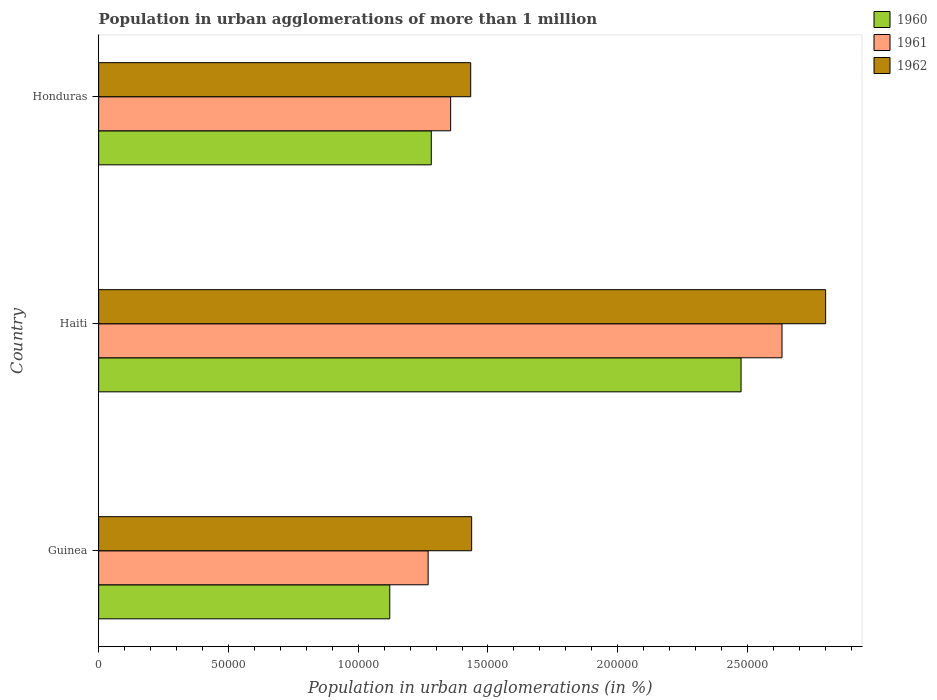How many bars are there on the 1st tick from the bottom?
Offer a terse response. 3. What is the label of the 3rd group of bars from the top?
Offer a very short reply. Guinea. In how many cases, is the number of bars for a given country not equal to the number of legend labels?
Offer a terse response. 0. What is the population in urban agglomerations in 1960 in Guinea?
Your response must be concise. 1.12e+05. Across all countries, what is the maximum population in urban agglomerations in 1960?
Provide a succinct answer. 2.47e+05. Across all countries, what is the minimum population in urban agglomerations in 1962?
Provide a succinct answer. 1.43e+05. In which country was the population in urban agglomerations in 1961 maximum?
Ensure brevity in your answer.  Haiti. In which country was the population in urban agglomerations in 1962 minimum?
Ensure brevity in your answer.  Honduras. What is the total population in urban agglomerations in 1962 in the graph?
Provide a short and direct response. 5.67e+05. What is the difference between the population in urban agglomerations in 1960 in Guinea and that in Haiti?
Offer a very short reply. -1.35e+05. What is the difference between the population in urban agglomerations in 1961 in Honduras and the population in urban agglomerations in 1962 in Haiti?
Offer a very short reply. -1.44e+05. What is the average population in urban agglomerations in 1961 per country?
Your response must be concise. 1.75e+05. What is the difference between the population in urban agglomerations in 1960 and population in urban agglomerations in 1962 in Honduras?
Provide a short and direct response. -1.52e+04. In how many countries, is the population in urban agglomerations in 1962 greater than 190000 %?
Provide a succinct answer. 1. What is the ratio of the population in urban agglomerations in 1960 in Guinea to that in Honduras?
Your answer should be compact. 0.88. Is the difference between the population in urban agglomerations in 1960 in Guinea and Honduras greater than the difference between the population in urban agglomerations in 1962 in Guinea and Honduras?
Your answer should be very brief. No. What is the difference between the highest and the second highest population in urban agglomerations in 1962?
Keep it short and to the point. 1.36e+05. What is the difference between the highest and the lowest population in urban agglomerations in 1962?
Your answer should be compact. 1.37e+05. In how many countries, is the population in urban agglomerations in 1962 greater than the average population in urban agglomerations in 1962 taken over all countries?
Offer a terse response. 1. Is the sum of the population in urban agglomerations in 1962 in Guinea and Haiti greater than the maximum population in urban agglomerations in 1961 across all countries?
Provide a short and direct response. Yes. What does the 2nd bar from the top in Haiti represents?
Provide a succinct answer. 1961. Are all the bars in the graph horizontal?
Keep it short and to the point. Yes. What is the difference between two consecutive major ticks on the X-axis?
Ensure brevity in your answer.  5.00e+04. Does the graph contain any zero values?
Keep it short and to the point. No. Does the graph contain grids?
Keep it short and to the point. No. Where does the legend appear in the graph?
Make the answer very short. Top right. What is the title of the graph?
Provide a short and direct response. Population in urban agglomerations of more than 1 million. Does "1991" appear as one of the legend labels in the graph?
Provide a short and direct response. No. What is the label or title of the X-axis?
Your answer should be very brief. Population in urban agglomerations (in %). What is the Population in urban agglomerations (in %) in 1960 in Guinea?
Offer a terse response. 1.12e+05. What is the Population in urban agglomerations (in %) of 1961 in Guinea?
Offer a very short reply. 1.27e+05. What is the Population in urban agglomerations (in %) of 1962 in Guinea?
Ensure brevity in your answer.  1.44e+05. What is the Population in urban agglomerations (in %) of 1960 in Haiti?
Provide a short and direct response. 2.47e+05. What is the Population in urban agglomerations (in %) of 1961 in Haiti?
Offer a terse response. 2.63e+05. What is the Population in urban agglomerations (in %) in 1962 in Haiti?
Offer a very short reply. 2.80e+05. What is the Population in urban agglomerations (in %) in 1960 in Honduras?
Your response must be concise. 1.28e+05. What is the Population in urban agglomerations (in %) of 1961 in Honduras?
Make the answer very short. 1.36e+05. What is the Population in urban agglomerations (in %) in 1962 in Honduras?
Ensure brevity in your answer.  1.43e+05. Across all countries, what is the maximum Population in urban agglomerations (in %) in 1960?
Offer a very short reply. 2.47e+05. Across all countries, what is the maximum Population in urban agglomerations (in %) in 1961?
Ensure brevity in your answer.  2.63e+05. Across all countries, what is the maximum Population in urban agglomerations (in %) of 1962?
Your answer should be very brief. 2.80e+05. Across all countries, what is the minimum Population in urban agglomerations (in %) in 1960?
Keep it short and to the point. 1.12e+05. Across all countries, what is the minimum Population in urban agglomerations (in %) of 1961?
Provide a succinct answer. 1.27e+05. Across all countries, what is the minimum Population in urban agglomerations (in %) of 1962?
Ensure brevity in your answer.  1.43e+05. What is the total Population in urban agglomerations (in %) in 1960 in the graph?
Keep it short and to the point. 4.88e+05. What is the total Population in urban agglomerations (in %) in 1961 in the graph?
Ensure brevity in your answer.  5.26e+05. What is the total Population in urban agglomerations (in %) of 1962 in the graph?
Keep it short and to the point. 5.67e+05. What is the difference between the Population in urban agglomerations (in %) in 1960 in Guinea and that in Haiti?
Provide a short and direct response. -1.35e+05. What is the difference between the Population in urban agglomerations (in %) in 1961 in Guinea and that in Haiti?
Provide a short and direct response. -1.36e+05. What is the difference between the Population in urban agglomerations (in %) in 1962 in Guinea and that in Haiti?
Keep it short and to the point. -1.36e+05. What is the difference between the Population in urban agglomerations (in %) in 1960 in Guinea and that in Honduras?
Offer a very short reply. -1.60e+04. What is the difference between the Population in urban agglomerations (in %) in 1961 in Guinea and that in Honduras?
Give a very brief answer. -8666. What is the difference between the Population in urban agglomerations (in %) in 1962 in Guinea and that in Honduras?
Provide a succinct answer. 365. What is the difference between the Population in urban agglomerations (in %) of 1960 in Haiti and that in Honduras?
Your answer should be very brief. 1.19e+05. What is the difference between the Population in urban agglomerations (in %) in 1961 in Haiti and that in Honduras?
Your answer should be very brief. 1.28e+05. What is the difference between the Population in urban agglomerations (in %) in 1962 in Haiti and that in Honduras?
Your answer should be compact. 1.37e+05. What is the difference between the Population in urban agglomerations (in %) in 1960 in Guinea and the Population in urban agglomerations (in %) in 1961 in Haiti?
Keep it short and to the point. -1.51e+05. What is the difference between the Population in urban agglomerations (in %) in 1960 in Guinea and the Population in urban agglomerations (in %) in 1962 in Haiti?
Your answer should be very brief. -1.68e+05. What is the difference between the Population in urban agglomerations (in %) of 1961 in Guinea and the Population in urban agglomerations (in %) of 1962 in Haiti?
Keep it short and to the point. -1.53e+05. What is the difference between the Population in urban agglomerations (in %) in 1960 in Guinea and the Population in urban agglomerations (in %) in 1961 in Honduras?
Provide a succinct answer. -2.35e+04. What is the difference between the Population in urban agglomerations (in %) of 1960 in Guinea and the Population in urban agglomerations (in %) of 1962 in Honduras?
Provide a short and direct response. -3.12e+04. What is the difference between the Population in urban agglomerations (in %) of 1961 in Guinea and the Population in urban agglomerations (in %) of 1962 in Honduras?
Ensure brevity in your answer.  -1.64e+04. What is the difference between the Population in urban agglomerations (in %) in 1960 in Haiti and the Population in urban agglomerations (in %) in 1961 in Honduras?
Your response must be concise. 1.12e+05. What is the difference between the Population in urban agglomerations (in %) in 1960 in Haiti and the Population in urban agglomerations (in %) in 1962 in Honduras?
Keep it short and to the point. 1.04e+05. What is the difference between the Population in urban agglomerations (in %) of 1961 in Haiti and the Population in urban agglomerations (in %) of 1962 in Honduras?
Provide a short and direct response. 1.20e+05. What is the average Population in urban agglomerations (in %) in 1960 per country?
Provide a succinct answer. 1.63e+05. What is the average Population in urban agglomerations (in %) in 1961 per country?
Provide a short and direct response. 1.75e+05. What is the average Population in urban agglomerations (in %) of 1962 per country?
Your answer should be compact. 1.89e+05. What is the difference between the Population in urban agglomerations (in %) of 1960 and Population in urban agglomerations (in %) of 1961 in Guinea?
Offer a very short reply. -1.48e+04. What is the difference between the Population in urban agglomerations (in %) of 1960 and Population in urban agglomerations (in %) of 1962 in Guinea?
Give a very brief answer. -3.15e+04. What is the difference between the Population in urban agglomerations (in %) in 1961 and Population in urban agglomerations (in %) in 1962 in Guinea?
Provide a short and direct response. -1.68e+04. What is the difference between the Population in urban agglomerations (in %) of 1960 and Population in urban agglomerations (in %) of 1961 in Haiti?
Make the answer very short. -1.58e+04. What is the difference between the Population in urban agglomerations (in %) of 1960 and Population in urban agglomerations (in %) of 1962 in Haiti?
Your answer should be very brief. -3.26e+04. What is the difference between the Population in urban agglomerations (in %) in 1961 and Population in urban agglomerations (in %) in 1962 in Haiti?
Offer a terse response. -1.68e+04. What is the difference between the Population in urban agglomerations (in %) in 1960 and Population in urban agglomerations (in %) in 1961 in Honduras?
Make the answer very short. -7454. What is the difference between the Population in urban agglomerations (in %) in 1960 and Population in urban agglomerations (in %) in 1962 in Honduras?
Provide a succinct answer. -1.52e+04. What is the difference between the Population in urban agglomerations (in %) of 1961 and Population in urban agglomerations (in %) of 1962 in Honduras?
Your answer should be very brief. -7731. What is the ratio of the Population in urban agglomerations (in %) in 1960 in Guinea to that in Haiti?
Offer a terse response. 0.45. What is the ratio of the Population in urban agglomerations (in %) of 1961 in Guinea to that in Haiti?
Offer a terse response. 0.48. What is the ratio of the Population in urban agglomerations (in %) of 1962 in Guinea to that in Haiti?
Offer a very short reply. 0.51. What is the ratio of the Population in urban agglomerations (in %) in 1960 in Guinea to that in Honduras?
Your answer should be compact. 0.88. What is the ratio of the Population in urban agglomerations (in %) in 1961 in Guinea to that in Honduras?
Offer a very short reply. 0.94. What is the ratio of the Population in urban agglomerations (in %) of 1960 in Haiti to that in Honduras?
Ensure brevity in your answer.  1.93. What is the ratio of the Population in urban agglomerations (in %) in 1961 in Haiti to that in Honduras?
Provide a succinct answer. 1.94. What is the ratio of the Population in urban agglomerations (in %) in 1962 in Haiti to that in Honduras?
Your answer should be very brief. 1.95. What is the difference between the highest and the second highest Population in urban agglomerations (in %) of 1960?
Your answer should be compact. 1.19e+05. What is the difference between the highest and the second highest Population in urban agglomerations (in %) in 1961?
Your answer should be very brief. 1.28e+05. What is the difference between the highest and the second highest Population in urban agglomerations (in %) of 1962?
Keep it short and to the point. 1.36e+05. What is the difference between the highest and the lowest Population in urban agglomerations (in %) of 1960?
Keep it short and to the point. 1.35e+05. What is the difference between the highest and the lowest Population in urban agglomerations (in %) of 1961?
Provide a succinct answer. 1.36e+05. What is the difference between the highest and the lowest Population in urban agglomerations (in %) in 1962?
Provide a short and direct response. 1.37e+05. 